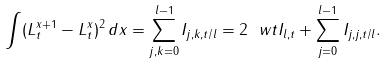Convert formula to latex. <formula><loc_0><loc_0><loc_500><loc_500>\int ( L ^ { x + 1 } _ { t } - L ^ { x } _ { t } ) ^ { 2 } \, d x = \sum _ { j , k = 0 } ^ { l - 1 } I _ { j , k , t / l } = 2 \ w t I _ { l , t } + \sum _ { j = 0 } ^ { l - 1 } I _ { j , j , t / l } .</formula> 